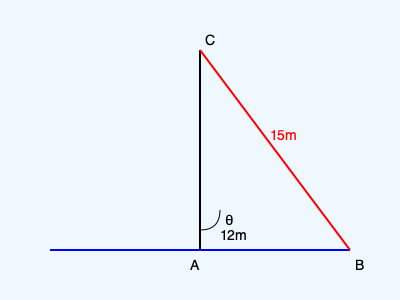A sailboat's mast (AC) is 15 meters long and forms a right angle with the deck (AB). The distance from the base of the mast to the point where the main sheet attaches to the deck (AB) is 12 meters. What is the angle θ between the mast and the main sheet? To solve this problem, we can use trigonometry in the right triangle ABC. Let's approach this step-by-step:

1) We know that:
   - The mast (AC) is 15 meters long
   - The distance from the mast base to the sheet attachment (AB) is 12 meters
   - The angle at A is a right angle (90°)

2) We need to find the angle θ, which is the angle between the mast and the main sheet.

3) This forms a right triangle, where:
   - The hypotenuse (AC) is 15m
   - The base (AB) is 12m
   - We need to find the angle opposite to AB

4) We can use the inverse cosine function (arccos) to find this angle:

   $$\cos(\theta) = \frac{\text{adjacent}}{\text{hypotenuse}} = \frac{12}{15} = \frac{4}{5}$$

5) Therefore:

   $$\theta = \arccos(\frac{4}{5})$$

6) Using a calculator or computer:

   $$\theta \approx 36.87°$$

7) Rounding to the nearest degree:

   $$\theta \approx 37°$$
Answer: 37° 